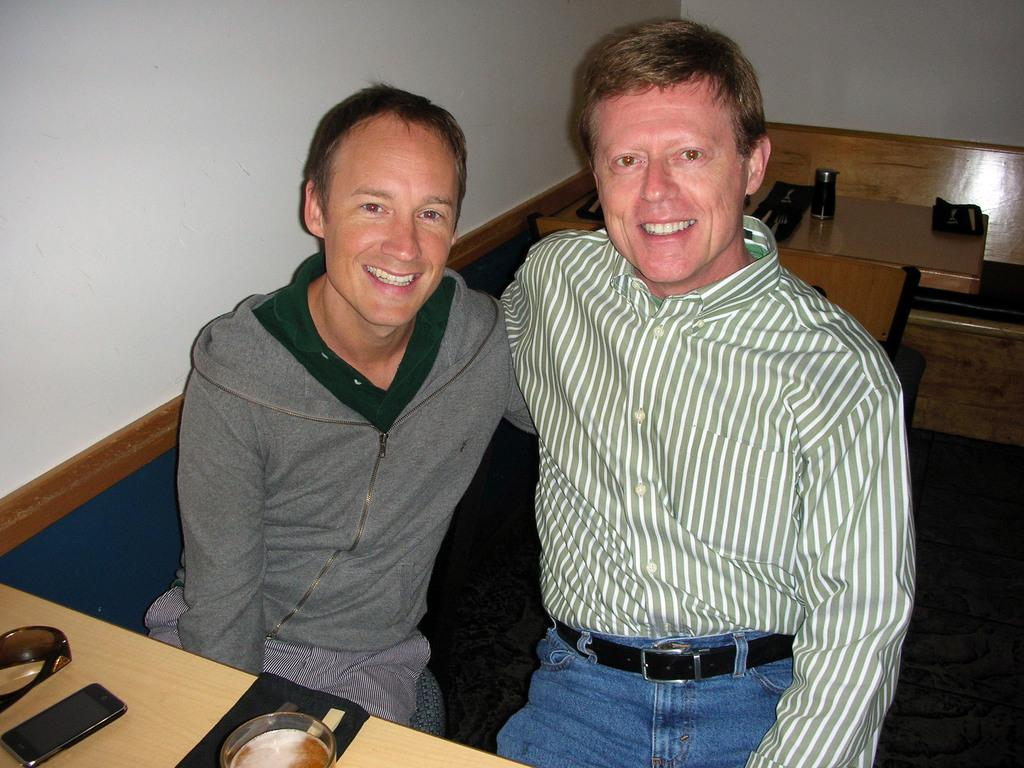How many people are present in the image? There are two persons sitting in the image. What is the facial expression of the persons in the image? The persons are smiling. What type of furniture can be seen in the image? There are tables and benches in the image. What objects are on the table in the image? There is a mobile, goggles, and a glass on the table. What is visible in the background of the image? There is a wall in the background of the image. What type of apparel is being traded between the two persons in the image? There is no indication of any apparel or trade taking place between the two persons in the image. 